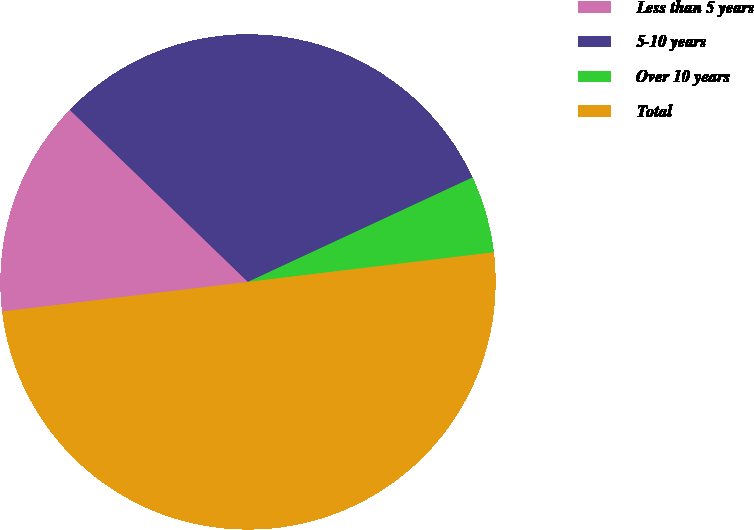<chart> <loc_0><loc_0><loc_500><loc_500><pie_chart><fcel>Less than 5 years<fcel>5-10 years<fcel>Over 10 years<fcel>Total<nl><fcel>14.13%<fcel>30.85%<fcel>5.02%<fcel>50.0%<nl></chart> 